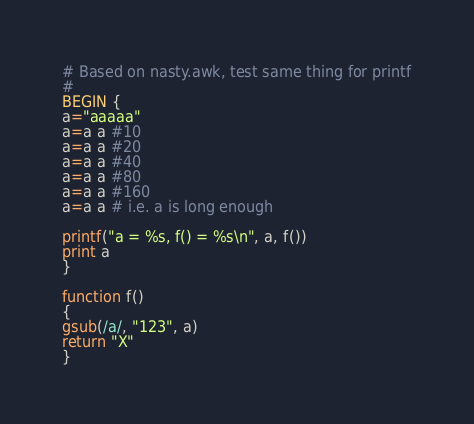Convert code to text. <code><loc_0><loc_0><loc_500><loc_500><_Awk_># Based on nasty.awk, test same thing for printf
#
BEGIN {
a="aaaaa"
a=a a #10
a=a a #20
a=a a #40
a=a a #80
a=a a #160
a=a a # i.e. a is long enough

printf("a = %s, f() = %s\n", a, f())
print a
}

function f()
{
gsub(/a/, "123", a)
return "X"
}
</code> 